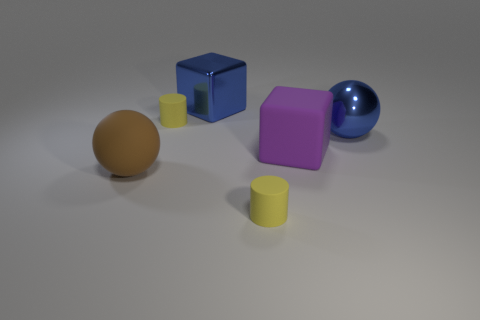Add 1 large rubber balls. How many objects exist? 7 Subtract all cylinders. How many objects are left? 4 Add 6 blue shiny objects. How many blue shiny objects are left? 8 Add 5 purple things. How many purple things exist? 6 Subtract 0 gray balls. How many objects are left? 6 Subtract all large things. Subtract all small yellow cylinders. How many objects are left? 0 